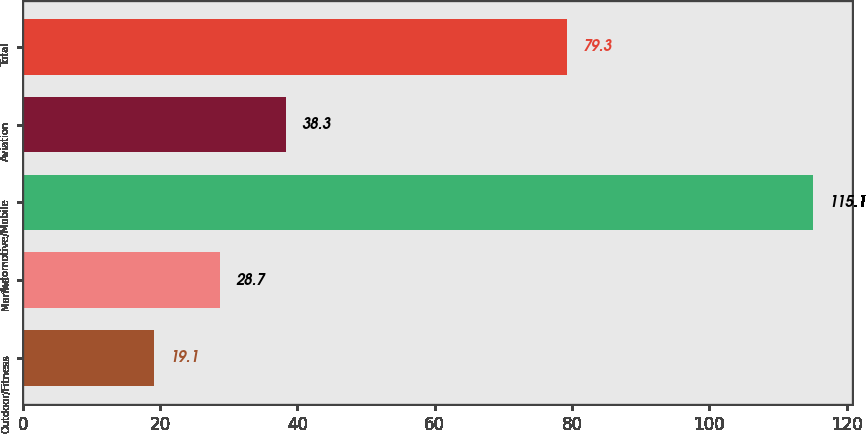<chart> <loc_0><loc_0><loc_500><loc_500><bar_chart><fcel>Outdoor/Fitness<fcel>Marine<fcel>Automotive/Mobile<fcel>Aviation<fcel>Total<nl><fcel>19.1<fcel>28.7<fcel>115.1<fcel>38.3<fcel>79.3<nl></chart> 